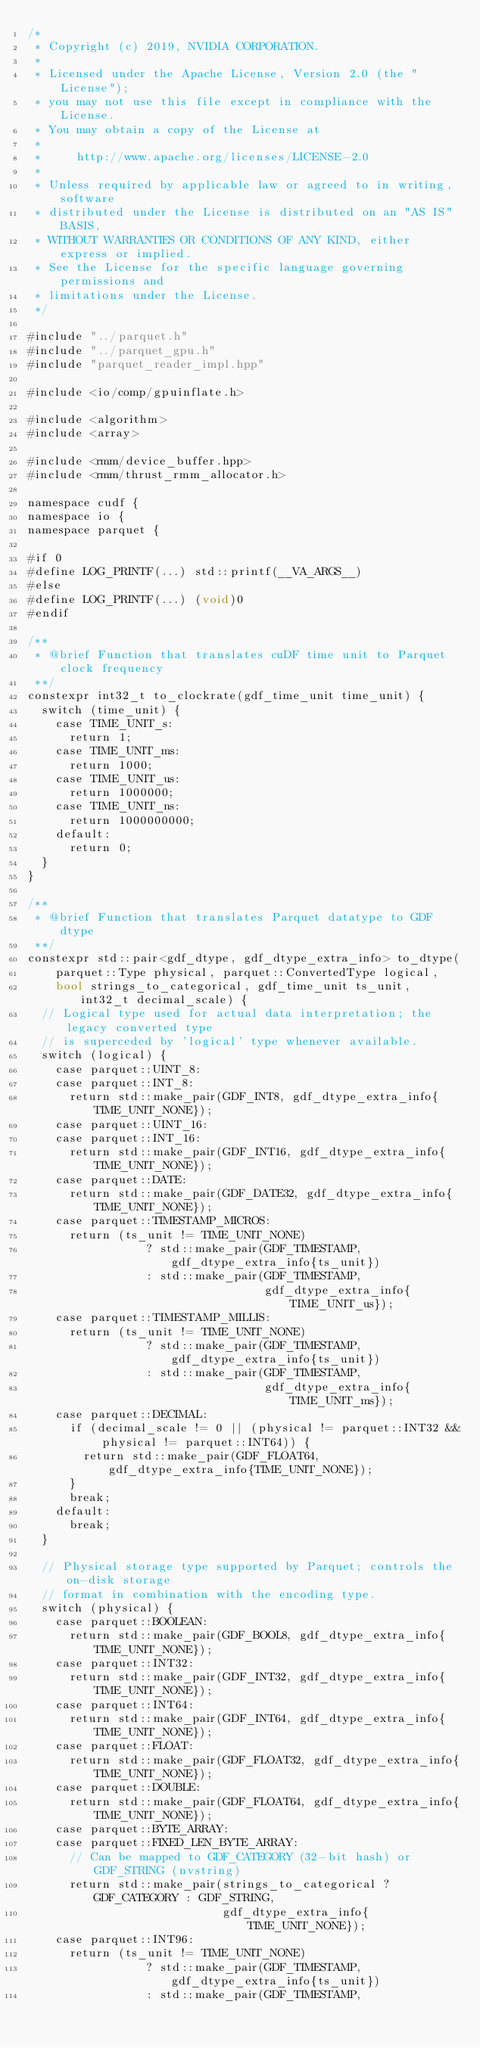Convert code to text. <code><loc_0><loc_0><loc_500><loc_500><_Cuda_>/*
 * Copyright (c) 2019, NVIDIA CORPORATION.
 *
 * Licensed under the Apache License, Version 2.0 (the "License");
 * you may not use this file except in compliance with the License.
 * You may obtain a copy of the License at
 *
 *     http://www.apache.org/licenses/LICENSE-2.0
 *
 * Unless required by applicable law or agreed to in writing, software
 * distributed under the License is distributed on an "AS IS" BASIS,
 * WITHOUT WARRANTIES OR CONDITIONS OF ANY KIND, either express or implied.
 * See the License for the specific language governing permissions and
 * limitations under the License.
 */

#include "../parquet.h"
#include "../parquet_gpu.h"
#include "parquet_reader_impl.hpp"

#include <io/comp/gpuinflate.h>

#include <algorithm>
#include <array>

#include <rmm/device_buffer.hpp>
#include <rmm/thrust_rmm_allocator.h>

namespace cudf {
namespace io {
namespace parquet {

#if 0
#define LOG_PRINTF(...) std::printf(__VA_ARGS__)
#else
#define LOG_PRINTF(...) (void)0
#endif

/**
 * @brief Function that translates cuDF time unit to Parquet clock frequency
 **/
constexpr int32_t to_clockrate(gdf_time_unit time_unit) {
  switch (time_unit) {
    case TIME_UNIT_s:
      return 1;
    case TIME_UNIT_ms:
      return 1000;
    case TIME_UNIT_us:
      return 1000000;
    case TIME_UNIT_ns:
      return 1000000000;
    default:
      return 0;
  }
}

/**
 * @brief Function that translates Parquet datatype to GDF dtype
 **/
constexpr std::pair<gdf_dtype, gdf_dtype_extra_info> to_dtype(
    parquet::Type physical, parquet::ConvertedType logical,
    bool strings_to_categorical, gdf_time_unit ts_unit, int32_t decimal_scale) {
  // Logical type used for actual data interpretation; the legacy converted type
  // is superceded by 'logical' type whenever available.
  switch (logical) {
    case parquet::UINT_8:
    case parquet::INT_8:
      return std::make_pair(GDF_INT8, gdf_dtype_extra_info{TIME_UNIT_NONE});
    case parquet::UINT_16:
    case parquet::INT_16:
      return std::make_pair(GDF_INT16, gdf_dtype_extra_info{TIME_UNIT_NONE});
    case parquet::DATE:
      return std::make_pair(GDF_DATE32, gdf_dtype_extra_info{TIME_UNIT_NONE});
    case parquet::TIMESTAMP_MICROS:
      return (ts_unit != TIME_UNIT_NONE)
                 ? std::make_pair(GDF_TIMESTAMP, gdf_dtype_extra_info{ts_unit})
                 : std::make_pair(GDF_TIMESTAMP,
                                  gdf_dtype_extra_info{TIME_UNIT_us});
    case parquet::TIMESTAMP_MILLIS:
      return (ts_unit != TIME_UNIT_NONE)
                 ? std::make_pair(GDF_TIMESTAMP, gdf_dtype_extra_info{ts_unit})
                 : std::make_pair(GDF_TIMESTAMP,
                                  gdf_dtype_extra_info{TIME_UNIT_ms});
    case parquet::DECIMAL:
      if (decimal_scale != 0 || (physical != parquet::INT32 && physical != parquet::INT64)) {
        return std::make_pair(GDF_FLOAT64, gdf_dtype_extra_info{TIME_UNIT_NONE});
      }
      break;
    default:
      break;
  }

  // Physical storage type supported by Parquet; controls the on-disk storage
  // format in combination with the encoding type.
  switch (physical) {
    case parquet::BOOLEAN:
      return std::make_pair(GDF_BOOL8, gdf_dtype_extra_info{TIME_UNIT_NONE});
    case parquet::INT32:
      return std::make_pair(GDF_INT32, gdf_dtype_extra_info{TIME_UNIT_NONE});
    case parquet::INT64:
      return std::make_pair(GDF_INT64, gdf_dtype_extra_info{TIME_UNIT_NONE});
    case parquet::FLOAT:
      return std::make_pair(GDF_FLOAT32, gdf_dtype_extra_info{TIME_UNIT_NONE});
    case parquet::DOUBLE:
      return std::make_pair(GDF_FLOAT64, gdf_dtype_extra_info{TIME_UNIT_NONE});
    case parquet::BYTE_ARRAY:
    case parquet::FIXED_LEN_BYTE_ARRAY:
      // Can be mapped to GDF_CATEGORY (32-bit hash) or GDF_STRING (nvstring)
      return std::make_pair(strings_to_categorical ? GDF_CATEGORY : GDF_STRING,
                            gdf_dtype_extra_info{TIME_UNIT_NONE});
    case parquet::INT96:
      return (ts_unit != TIME_UNIT_NONE)
                 ? std::make_pair(GDF_TIMESTAMP, gdf_dtype_extra_info{ts_unit})
                 : std::make_pair(GDF_TIMESTAMP,</code> 